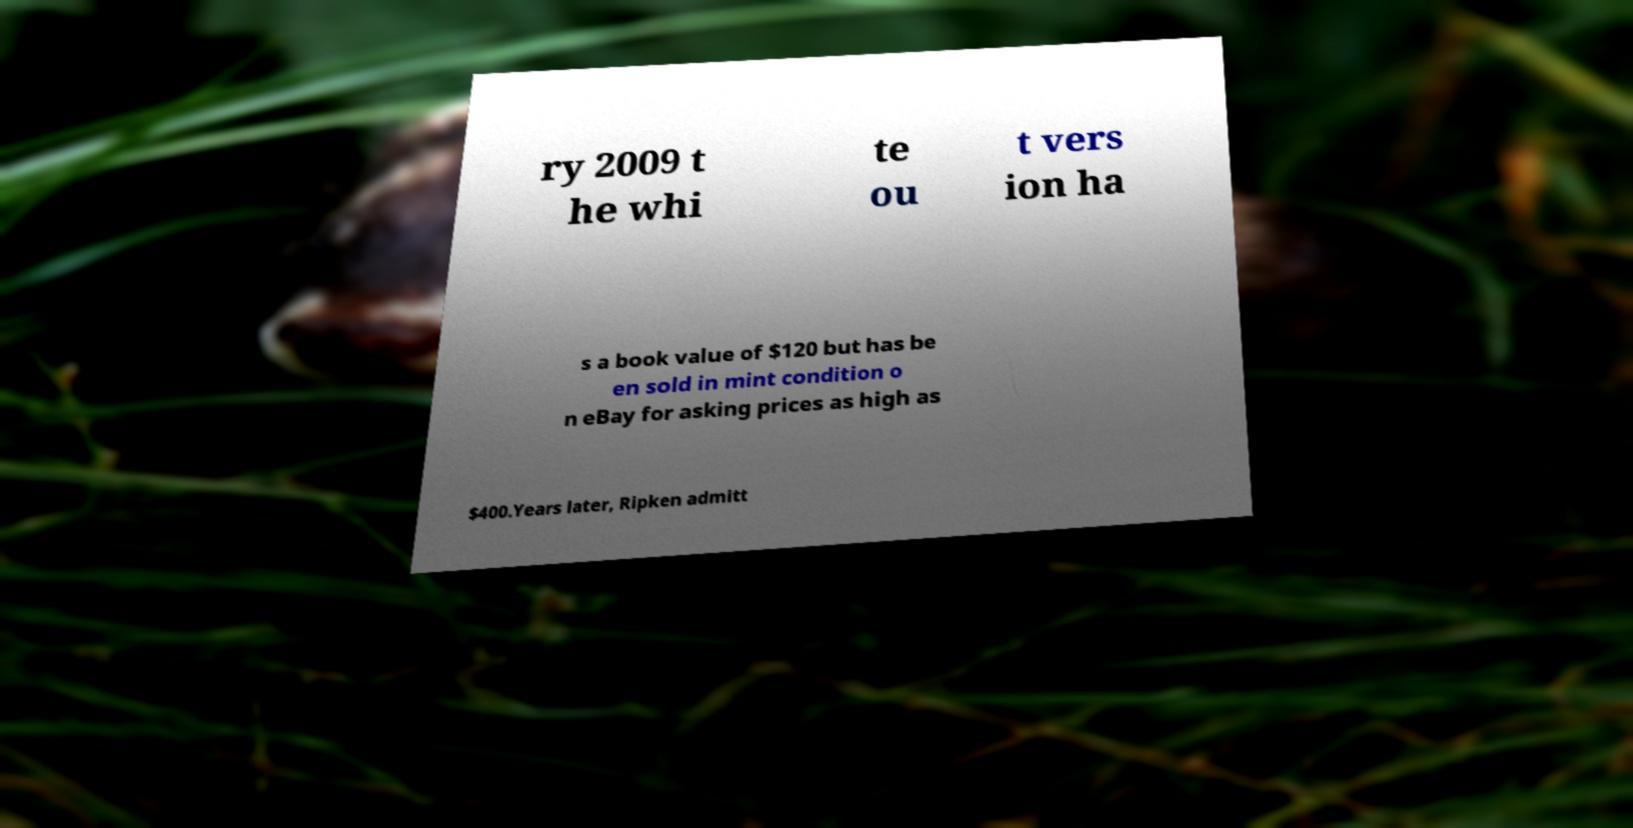There's text embedded in this image that I need extracted. Can you transcribe it verbatim? ry 2009 t he whi te ou t vers ion ha s a book value of $120 but has be en sold in mint condition o n eBay for asking prices as high as $400.Years later, Ripken admitt 